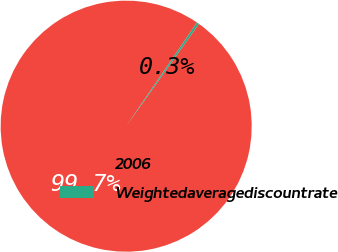Convert chart to OTSL. <chart><loc_0><loc_0><loc_500><loc_500><pie_chart><fcel>2006<fcel>Weightedaveragediscountrate<nl><fcel>99.7%<fcel>0.3%<nl></chart> 